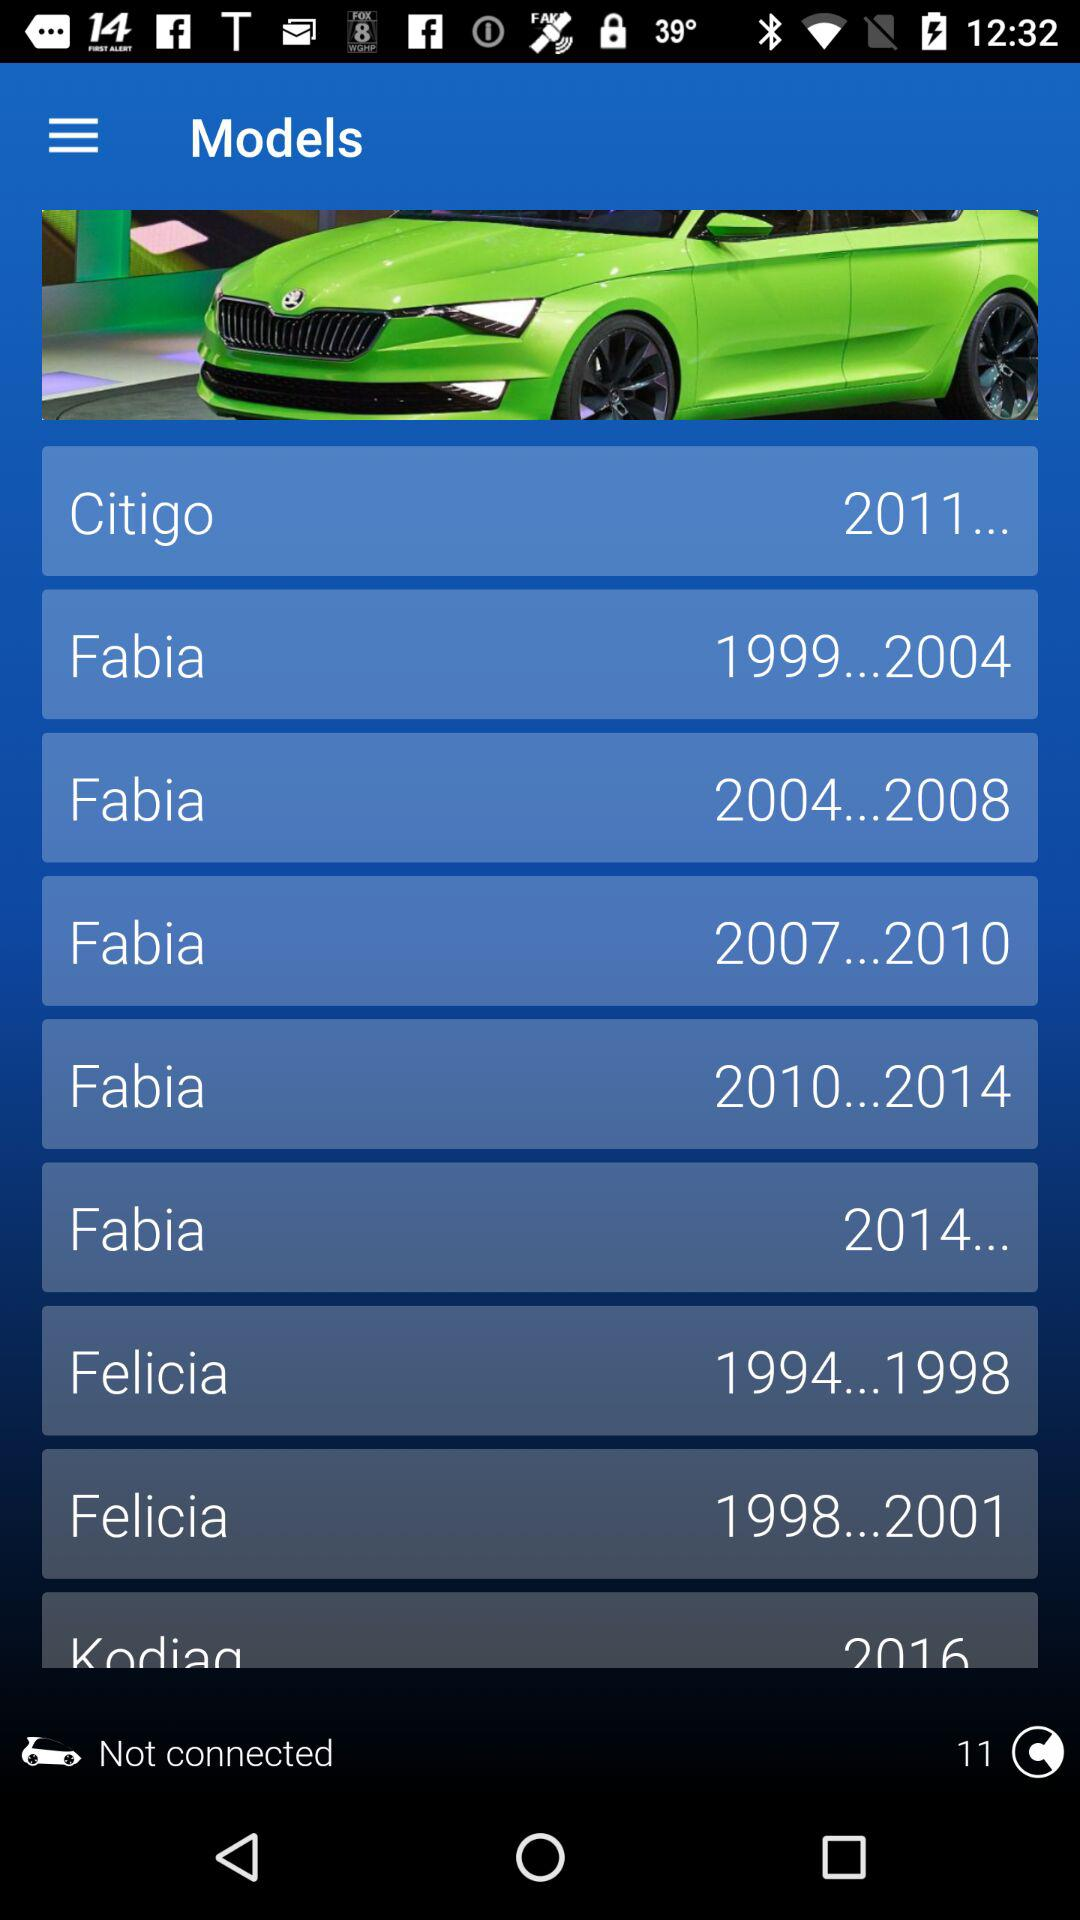When was the Citigo manufactured? The Citigo was manufactured in 2011. 